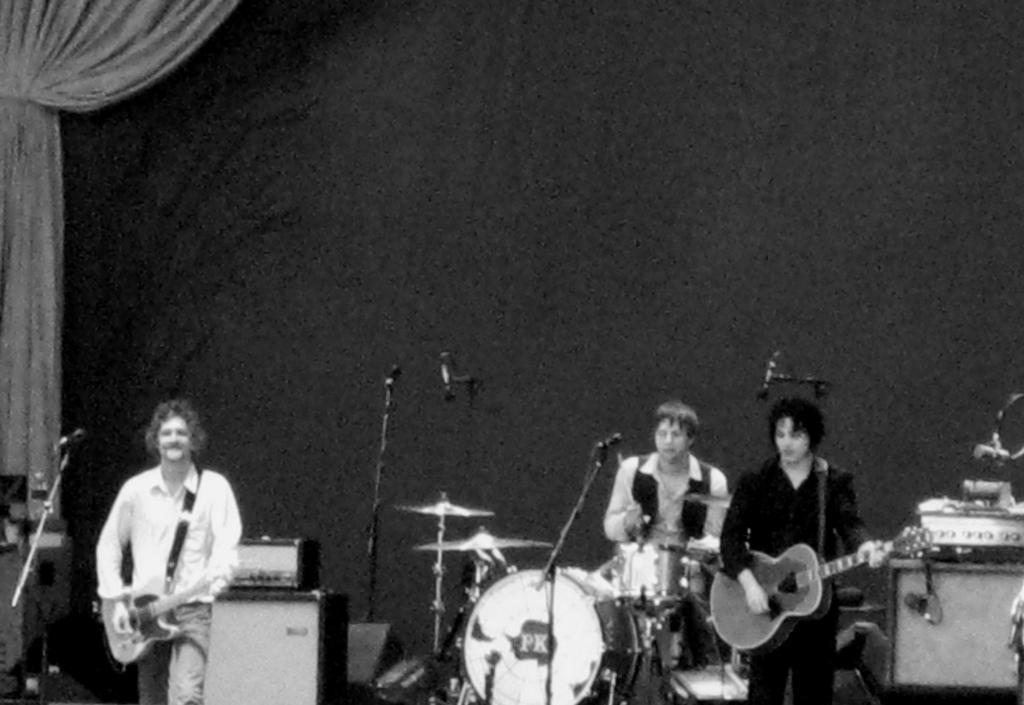How would you summarize this image in a sentence or two? In this image, There are some people standing and there are some music instruments and there are some microphones which are in black color, In the background there is a wall of black color and in the left side there is a white color curtain. 